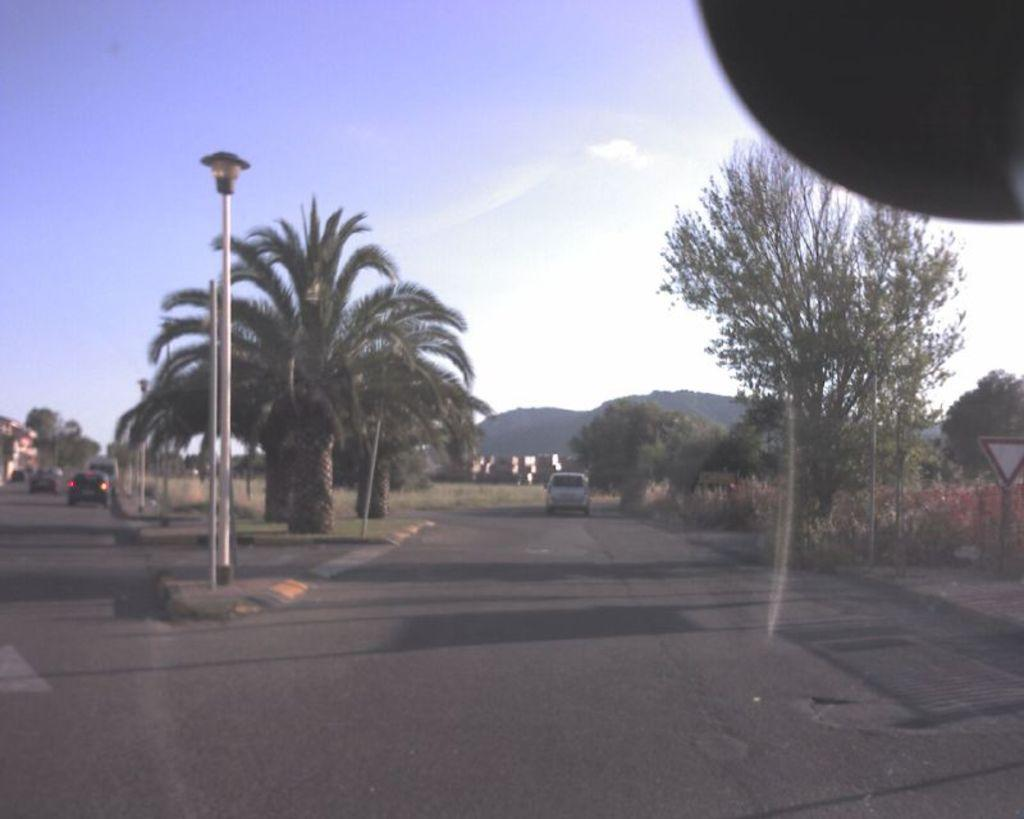What can be seen in the foreground of the image? In the foreground of the image, there are roads, poles, a board, trees, and plants. What is happening on the roads in the foreground of the image? Vehicles are moving on the roads in the foreground of the image. What is visible in the background of the image? In the background of the image, there are mountains and the sky. How many points does the landmark have in the image? There is no landmark with points mentioned in the image. Can you explain how the plants push the vehicles on the roads? The plants in the image do not have the ability to push the vehicles; they are stationary. 